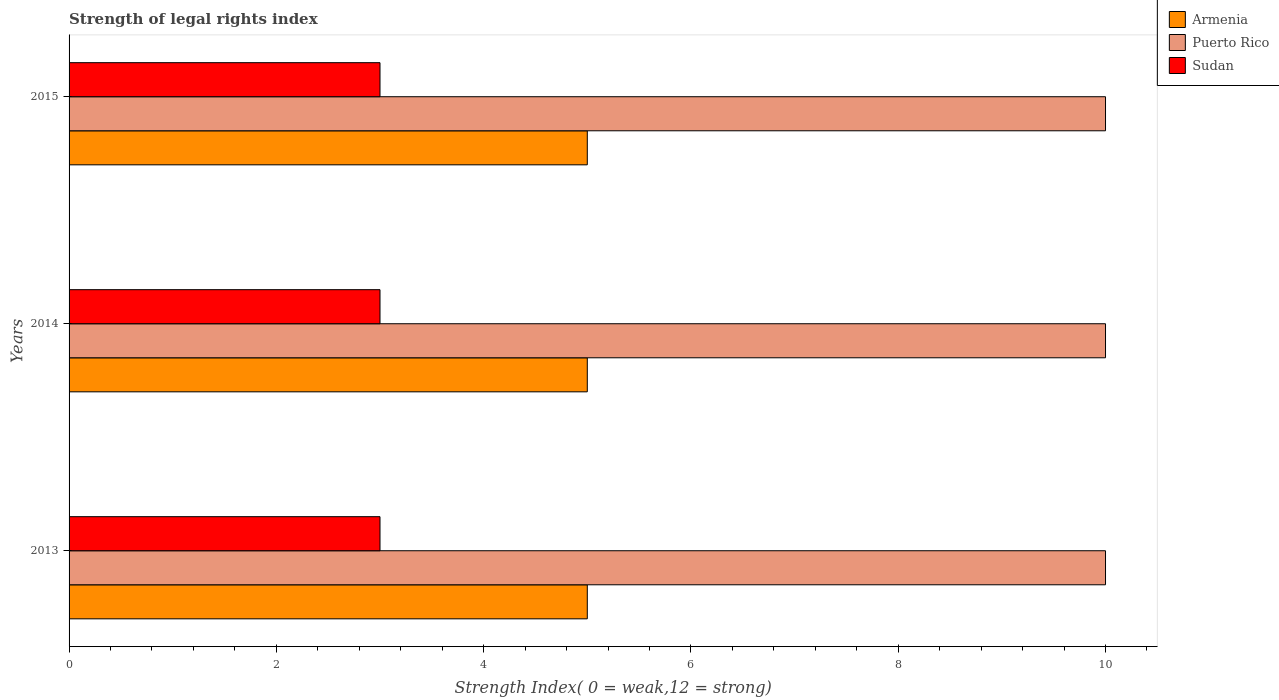How many different coloured bars are there?
Keep it short and to the point. 3. How many bars are there on the 3rd tick from the bottom?
Your response must be concise. 3. In how many cases, is the number of bars for a given year not equal to the number of legend labels?
Provide a short and direct response. 0. What is the strength index in Sudan in 2014?
Make the answer very short. 3. Across all years, what is the maximum strength index in Armenia?
Ensure brevity in your answer.  5. Across all years, what is the minimum strength index in Sudan?
Make the answer very short. 3. What is the total strength index in Sudan in the graph?
Make the answer very short. 9. What is the difference between the strength index in Armenia in 2014 and the strength index in Sudan in 2015?
Your response must be concise. 2. What is the average strength index in Puerto Rico per year?
Offer a terse response. 10. In the year 2014, what is the difference between the strength index in Armenia and strength index in Sudan?
Your answer should be compact. 2. In how many years, is the strength index in Puerto Rico greater than 3.6 ?
Provide a succinct answer. 3. Is the strength index in Sudan in 2013 less than that in 2015?
Offer a terse response. No. Is the difference between the strength index in Armenia in 2013 and 2014 greater than the difference between the strength index in Sudan in 2013 and 2014?
Your answer should be compact. No. What is the difference between the highest and the lowest strength index in Puerto Rico?
Offer a very short reply. 0. In how many years, is the strength index in Armenia greater than the average strength index in Armenia taken over all years?
Offer a terse response. 0. What does the 2nd bar from the top in 2014 represents?
Your response must be concise. Puerto Rico. What does the 3rd bar from the bottom in 2014 represents?
Your response must be concise. Sudan. How many bars are there?
Provide a succinct answer. 9. How many years are there in the graph?
Keep it short and to the point. 3. What is the difference between two consecutive major ticks on the X-axis?
Give a very brief answer. 2. Does the graph contain grids?
Keep it short and to the point. No. How many legend labels are there?
Your answer should be compact. 3. How are the legend labels stacked?
Offer a terse response. Vertical. What is the title of the graph?
Provide a short and direct response. Strength of legal rights index. Does "Kuwait" appear as one of the legend labels in the graph?
Offer a terse response. No. What is the label or title of the X-axis?
Provide a succinct answer. Strength Index( 0 = weak,12 = strong). What is the Strength Index( 0 = weak,12 = strong) in Sudan in 2013?
Offer a terse response. 3. What is the Strength Index( 0 = weak,12 = strong) in Puerto Rico in 2014?
Offer a very short reply. 10. What is the Strength Index( 0 = weak,12 = strong) in Sudan in 2014?
Ensure brevity in your answer.  3. What is the Strength Index( 0 = weak,12 = strong) in Puerto Rico in 2015?
Your answer should be compact. 10. What is the Strength Index( 0 = weak,12 = strong) in Sudan in 2015?
Keep it short and to the point. 3. What is the total Strength Index( 0 = weak,12 = strong) in Sudan in the graph?
Provide a succinct answer. 9. What is the difference between the Strength Index( 0 = weak,12 = strong) in Puerto Rico in 2013 and that in 2014?
Provide a succinct answer. 0. What is the difference between the Strength Index( 0 = weak,12 = strong) of Sudan in 2013 and that in 2014?
Your answer should be very brief. 0. What is the difference between the Strength Index( 0 = weak,12 = strong) of Puerto Rico in 2013 and that in 2015?
Ensure brevity in your answer.  0. What is the difference between the Strength Index( 0 = weak,12 = strong) in Sudan in 2013 and that in 2015?
Offer a terse response. 0. What is the difference between the Strength Index( 0 = weak,12 = strong) of Armenia in 2014 and that in 2015?
Provide a short and direct response. 0. What is the difference between the Strength Index( 0 = weak,12 = strong) of Armenia in 2013 and the Strength Index( 0 = weak,12 = strong) of Puerto Rico in 2014?
Give a very brief answer. -5. What is the difference between the Strength Index( 0 = weak,12 = strong) in Armenia in 2013 and the Strength Index( 0 = weak,12 = strong) in Sudan in 2014?
Give a very brief answer. 2. What is the difference between the Strength Index( 0 = weak,12 = strong) in Puerto Rico in 2013 and the Strength Index( 0 = weak,12 = strong) in Sudan in 2014?
Provide a succinct answer. 7. What is the difference between the Strength Index( 0 = weak,12 = strong) in Puerto Rico in 2013 and the Strength Index( 0 = weak,12 = strong) in Sudan in 2015?
Give a very brief answer. 7. What is the difference between the Strength Index( 0 = weak,12 = strong) in Armenia in 2014 and the Strength Index( 0 = weak,12 = strong) in Sudan in 2015?
Your answer should be very brief. 2. What is the difference between the Strength Index( 0 = weak,12 = strong) of Puerto Rico in 2014 and the Strength Index( 0 = weak,12 = strong) of Sudan in 2015?
Your response must be concise. 7. What is the average Strength Index( 0 = weak,12 = strong) of Armenia per year?
Your answer should be very brief. 5. In the year 2013, what is the difference between the Strength Index( 0 = weak,12 = strong) of Puerto Rico and Strength Index( 0 = weak,12 = strong) of Sudan?
Your response must be concise. 7. In the year 2014, what is the difference between the Strength Index( 0 = weak,12 = strong) in Armenia and Strength Index( 0 = weak,12 = strong) in Puerto Rico?
Offer a very short reply. -5. In the year 2014, what is the difference between the Strength Index( 0 = weak,12 = strong) of Puerto Rico and Strength Index( 0 = weak,12 = strong) of Sudan?
Give a very brief answer. 7. What is the ratio of the Strength Index( 0 = weak,12 = strong) in Sudan in 2013 to that in 2014?
Your answer should be very brief. 1. What is the ratio of the Strength Index( 0 = weak,12 = strong) of Sudan in 2013 to that in 2015?
Keep it short and to the point. 1. What is the ratio of the Strength Index( 0 = weak,12 = strong) in Puerto Rico in 2014 to that in 2015?
Provide a short and direct response. 1. What is the difference between the highest and the lowest Strength Index( 0 = weak,12 = strong) in Armenia?
Make the answer very short. 0. What is the difference between the highest and the lowest Strength Index( 0 = weak,12 = strong) of Sudan?
Give a very brief answer. 0. 